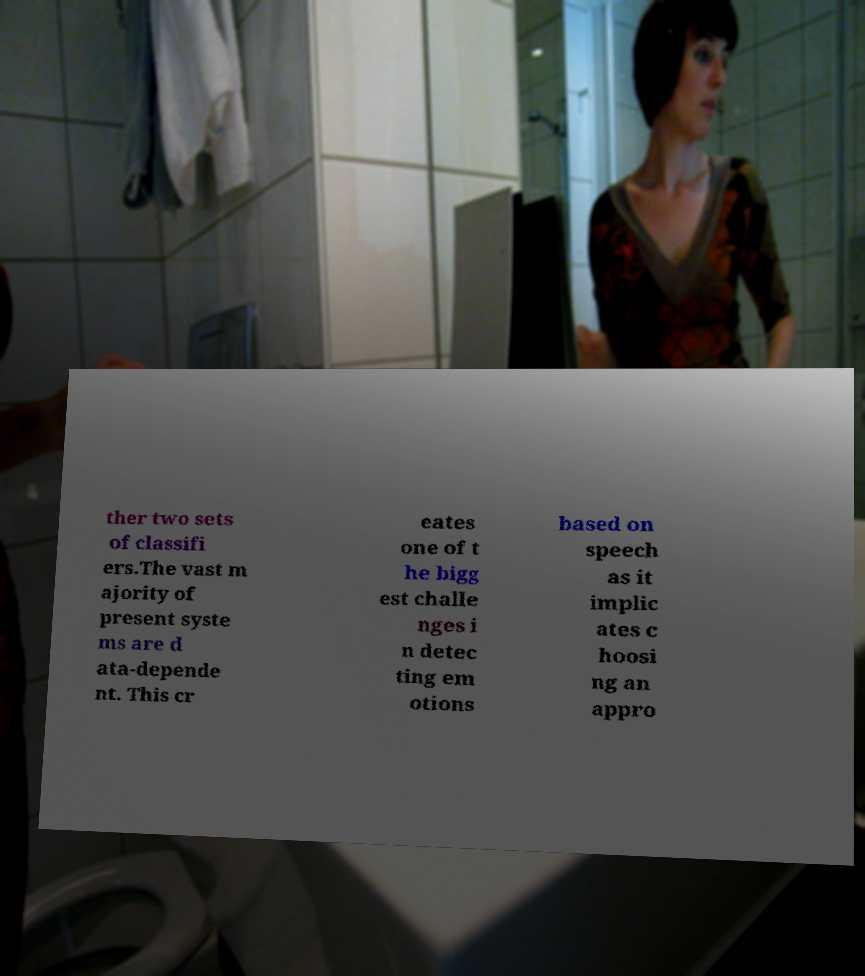What messages or text are displayed in this image? I need them in a readable, typed format. ther two sets of classifi ers.The vast m ajority of present syste ms are d ata-depende nt. This cr eates one of t he bigg est challe nges i n detec ting em otions based on speech as it implic ates c hoosi ng an appro 